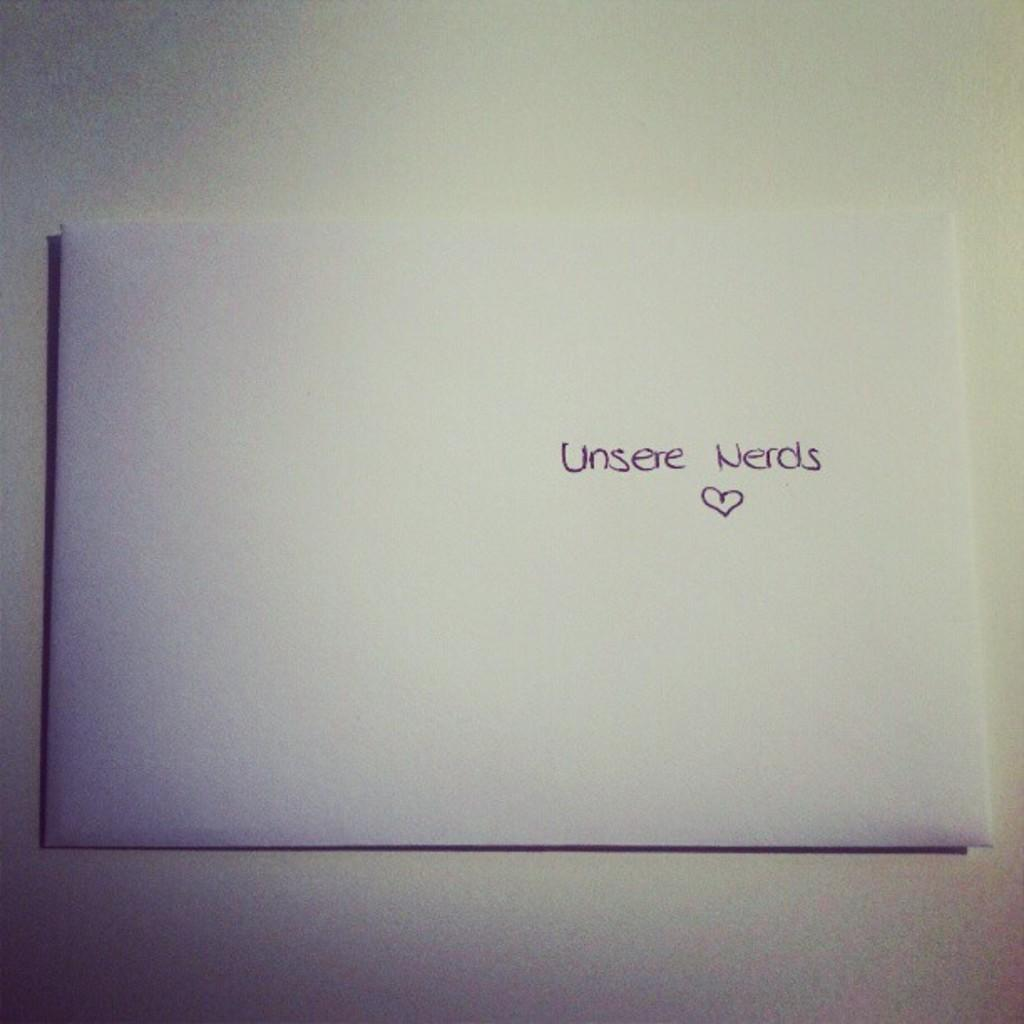<image>
Render a clear and concise summary of the photo. An envelope with the words "Unsere Nerds" and a heart. 